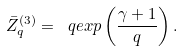Convert formula to latex. <formula><loc_0><loc_0><loc_500><loc_500>\bar { Z } _ { q } ^ { ( 3 ) } = \ q e x p \left ( \frac { \gamma + 1 } { q } \right ) .</formula> 